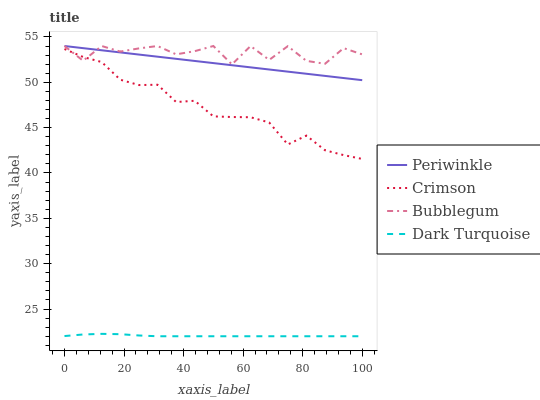Does Dark Turquoise have the minimum area under the curve?
Answer yes or no. Yes. Does Bubblegum have the maximum area under the curve?
Answer yes or no. Yes. Does Periwinkle have the minimum area under the curve?
Answer yes or no. No. Does Periwinkle have the maximum area under the curve?
Answer yes or no. No. Is Periwinkle the smoothest?
Answer yes or no. Yes. Is Bubblegum the roughest?
Answer yes or no. Yes. Is Dark Turquoise the smoothest?
Answer yes or no. No. Is Dark Turquoise the roughest?
Answer yes or no. No. Does Periwinkle have the lowest value?
Answer yes or no. No. Does Bubblegum have the highest value?
Answer yes or no. Yes. Does Dark Turquoise have the highest value?
Answer yes or no. No. Is Dark Turquoise less than Bubblegum?
Answer yes or no. Yes. Is Periwinkle greater than Dark Turquoise?
Answer yes or no. Yes. Does Crimson intersect Bubblegum?
Answer yes or no. Yes. Is Crimson less than Bubblegum?
Answer yes or no. No. Is Crimson greater than Bubblegum?
Answer yes or no. No. Does Dark Turquoise intersect Bubblegum?
Answer yes or no. No. 